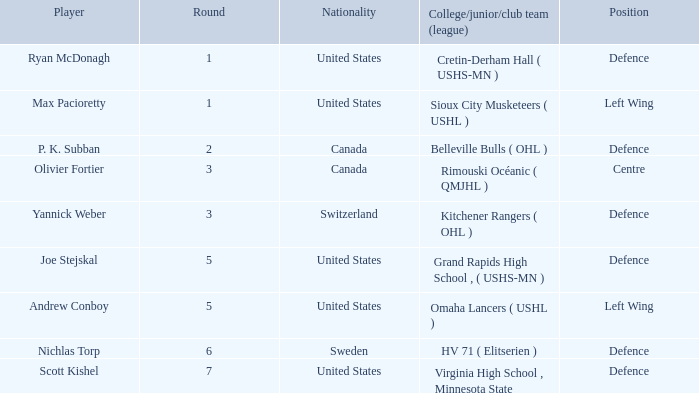Which College/junior/club team (league) was the player from Switzerland from? Kitchener Rangers ( OHL ). 